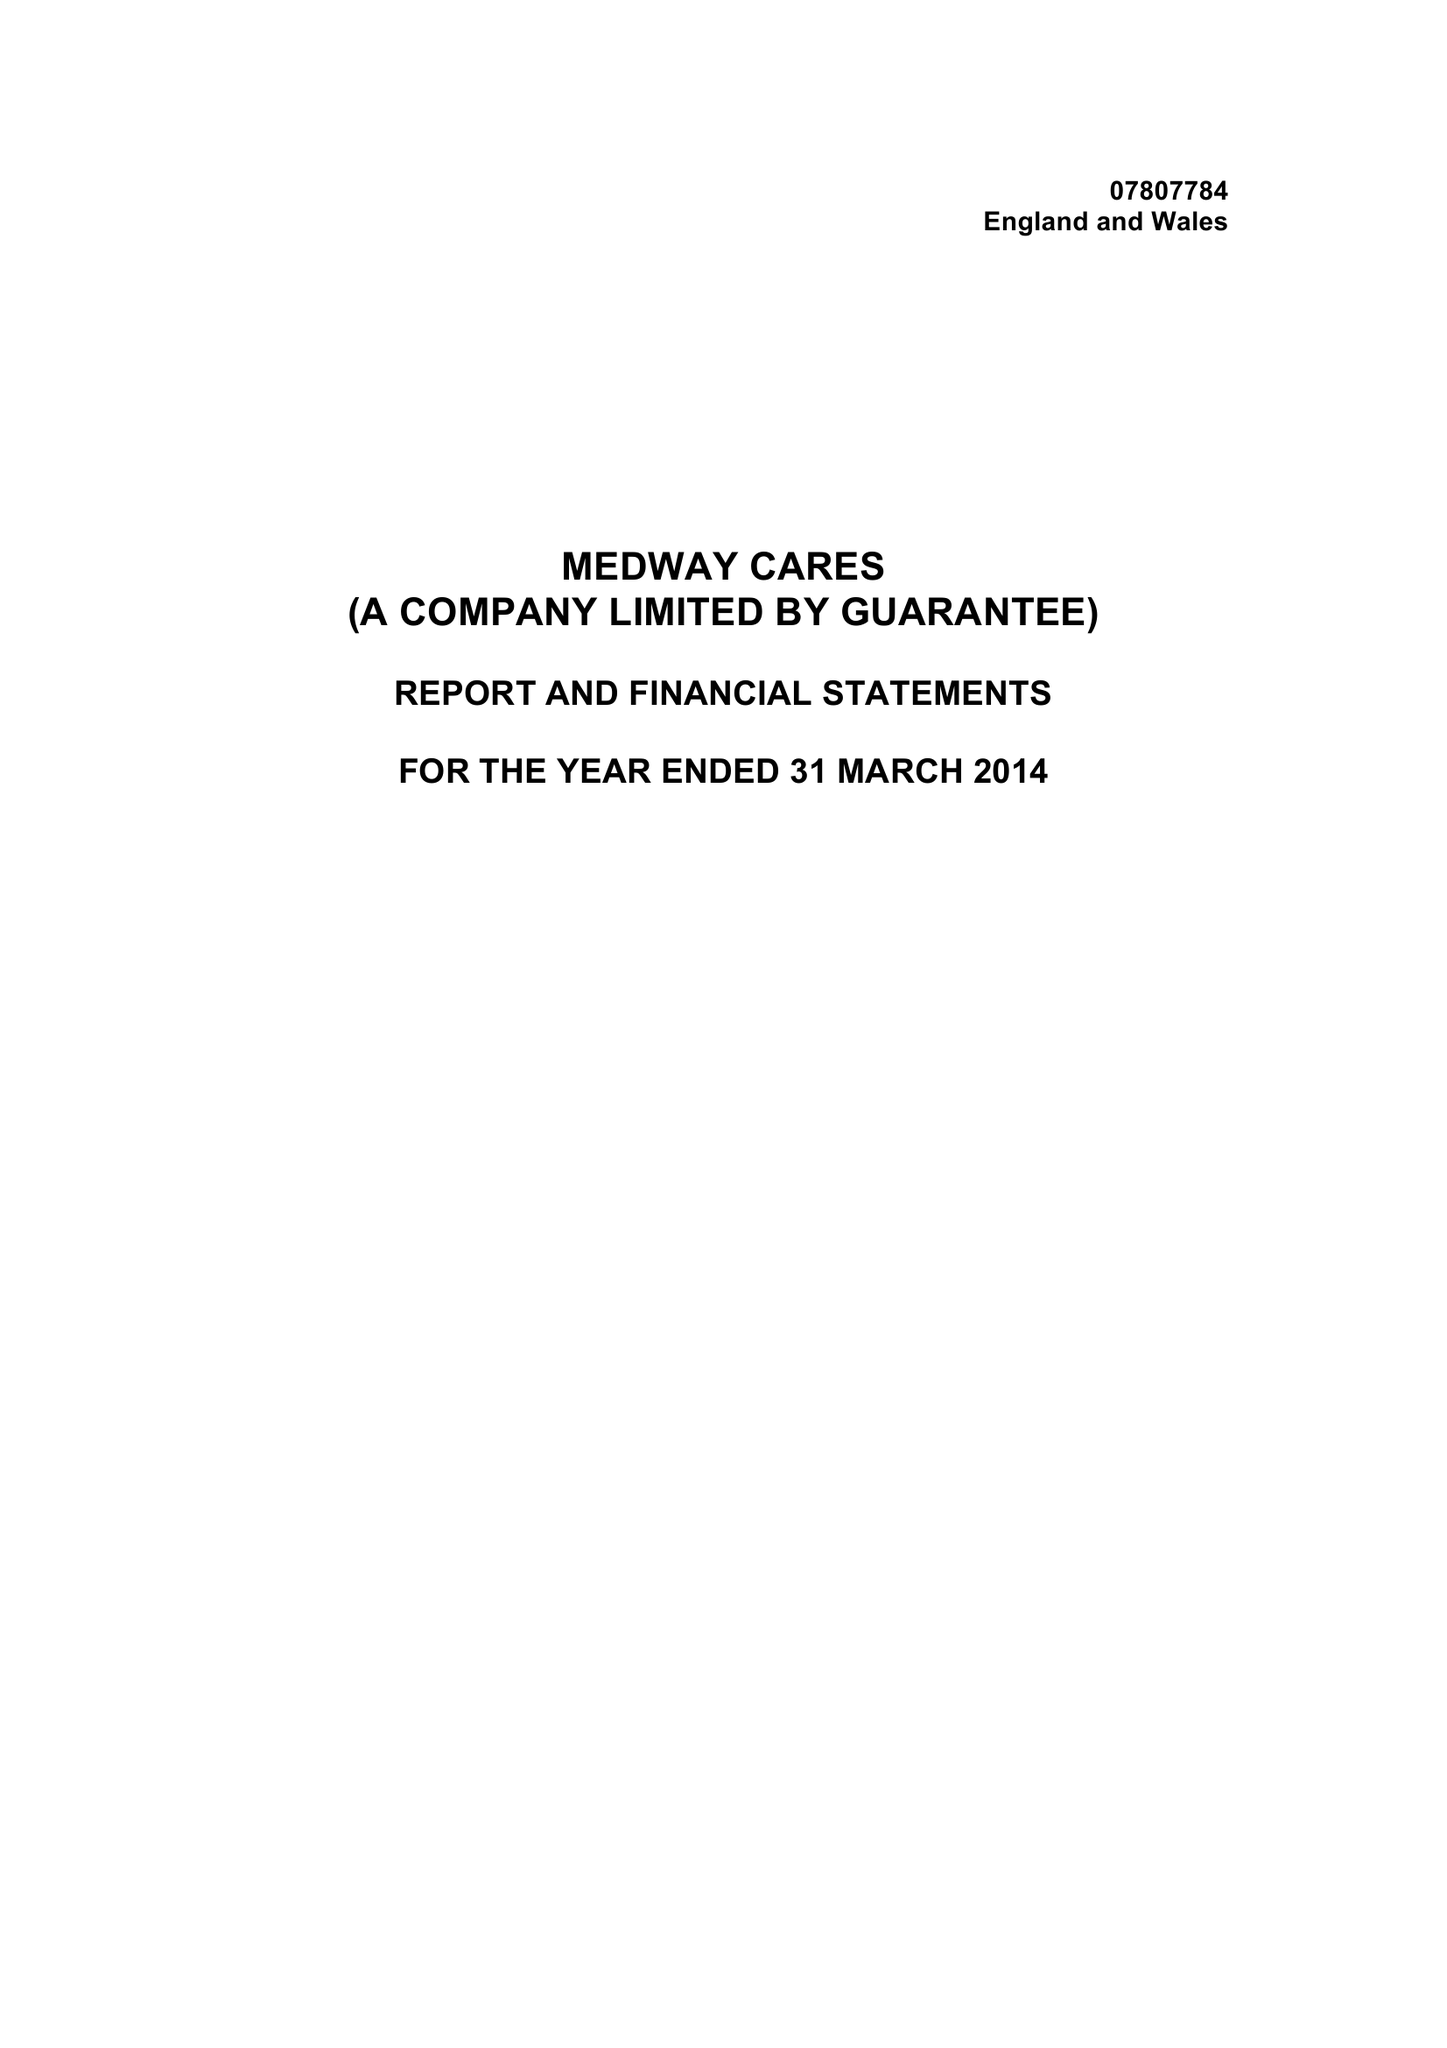What is the value for the report_date?
Answer the question using a single word or phrase. 2014-03-31 